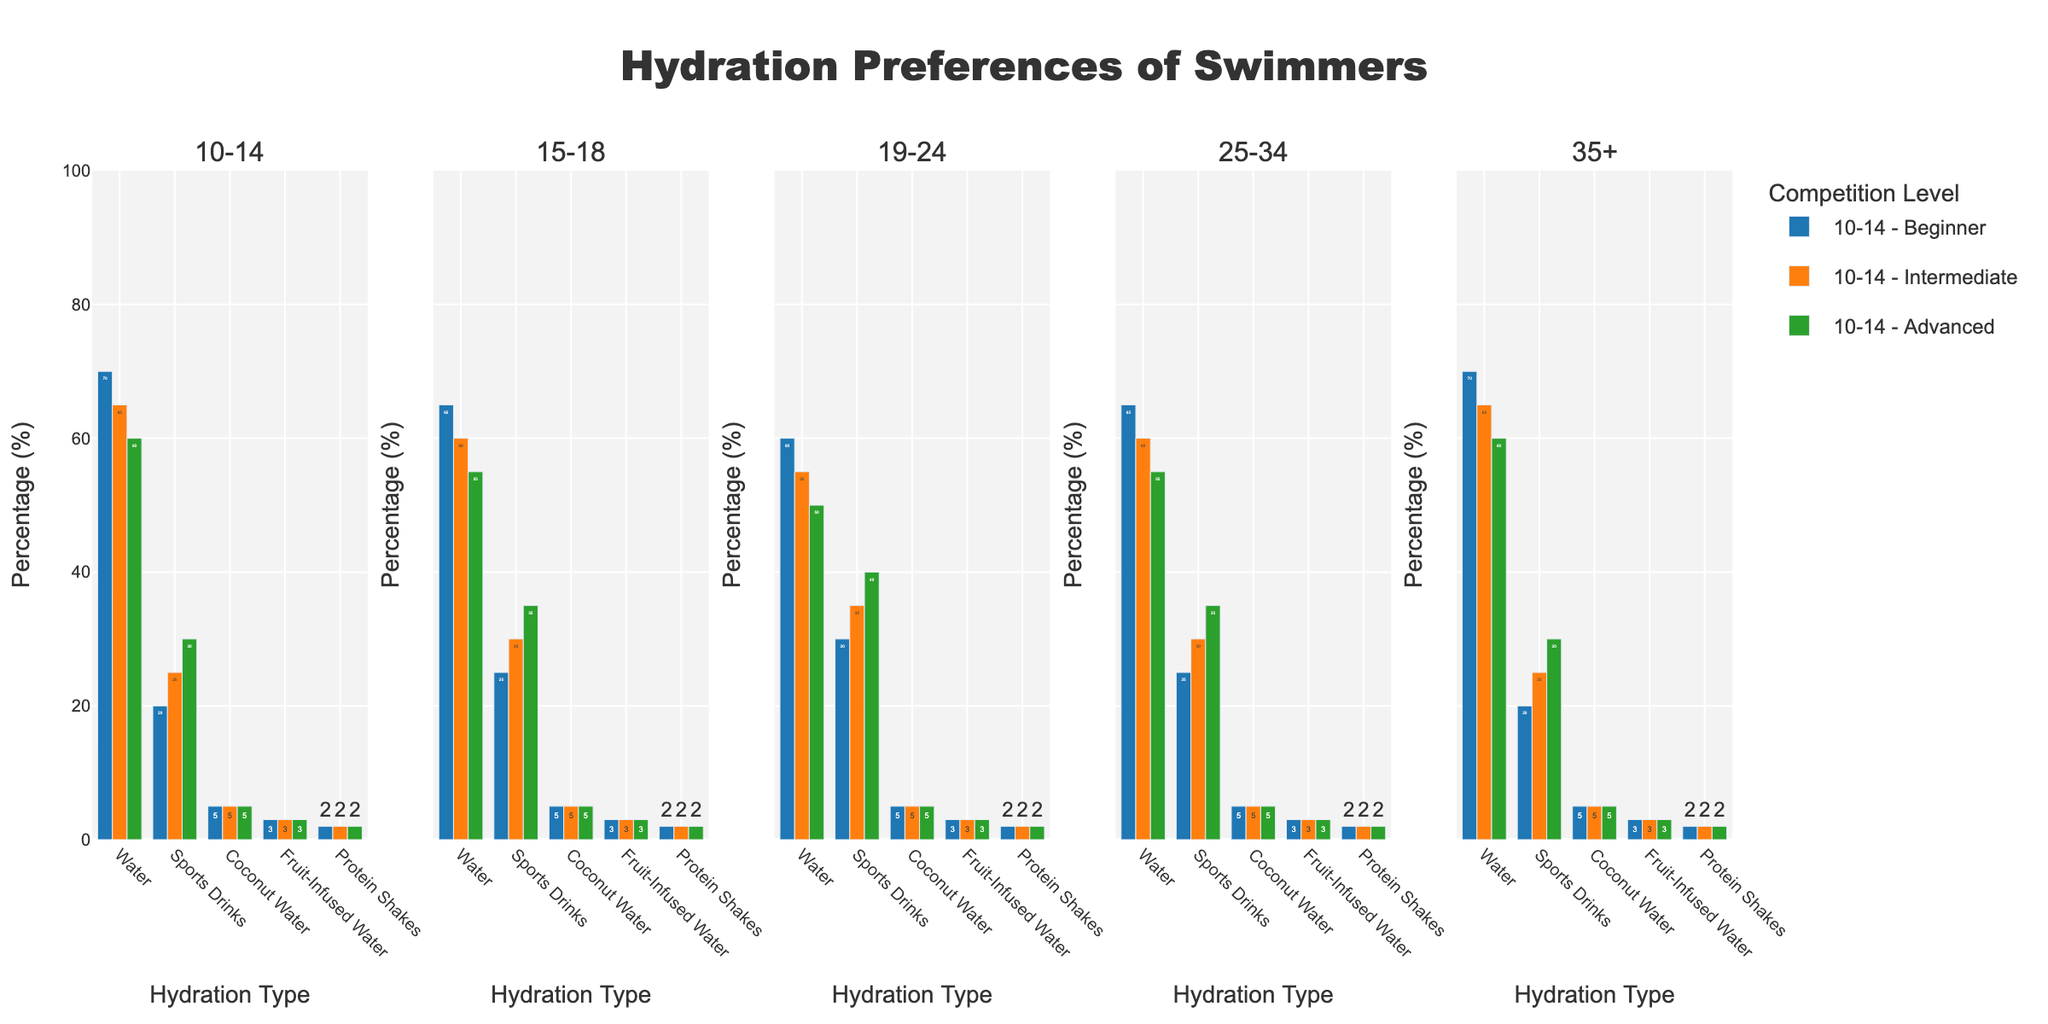What is the most preferred hydration type for beginner swimmers aged 10-14? Beginner swimmers aged 10-14 favor water the most, as indicated by the highest visible bar for this group under 'Water'.
Answer: Water How does the preference for sports drinks change from beginner to advanced competition levels for swimmers aged 19-24? The preference for sports drinks increases from beginner (30%) to intermediate (35%) to advanced (40%) for swimmers aged 19-24, as shown by the progressively taller bars.
Answer: Increases Which age group has the highest preference for coconut water regardless of competition level? All age groups show the same height for coconut water bars, indicating a 5% preference. Therefore, no age group has a distinct highest preference.
Answer: Equal for all What is the difference in water preference between beginner and advanced swimmers in the 15-18 age group? The water preference for beginner swimmers is 65%, and for advanced swimmers, it is 55%. The difference is 65% - 55% = 10%.
Answer: 10% In the 25-34 age group, which competition level shows the highest preference for sports drinks? The bar for sports drinks in the advanced competition level is the tallest among the 25-34 age group, indicating the highest preference at 35%.
Answer: Advanced Compare the preference for fruit-infused water between intermediate and beginner levels for the 35+ age group. Both beginner and intermediate levels show equal preference for fruit-infused water at 3%, indicated by bars of the same height.
Answer: Equal What is the sum of the preferences for water and protein shakes among advanced swimmers aged 10-14? The percentages for water and protein shakes are 60% and 2%, respectively. Summing them up: 60% + 2% = 62%.
Answer: 62% How does the preference for protein shakes across all age groups and competition levels compare? The preference for protein shakes remains consistently at 2% across all age groups and competition levels, as indicated by bars of uniform height.
Answer: Consistent at 2% Which hydration type is least preferred by intermediate swimmers aged 15-18? For intermediate swimmers aged 15-18, the shortest bars represent coconut water and protein shakes, both with 5% preference.
Answer: Coconut Water & Protein Shakes What is the average preference for fruit-infused water for advanced swimmers across all age groups? Advanced swimmers across all age groups have a consistent preference of 3% for fruit-infused water. The average is (3% + 3% + 3% + 3% + 3%)/5 = 3%.
Answer: 3% 